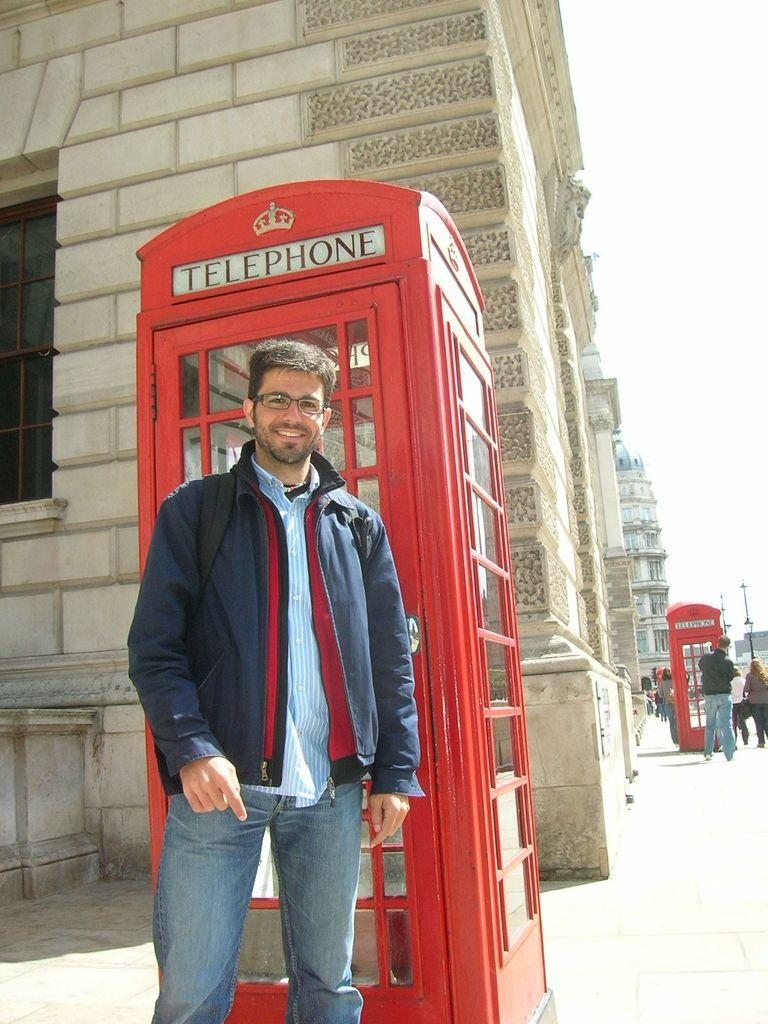What is the main subject of the image? There is a person standing in the center of the image. What is the person doing in the image? The person is smiling. What can be seen in the background of the image? There are buildings, telephone booths, trees, and people in the background of the image. What is the color of the sky visible in the background? The sky is visible in the background of the image, but the color is not mentioned in the facts. How many cakes can be seen in the image? There are no cakes present in the image. 